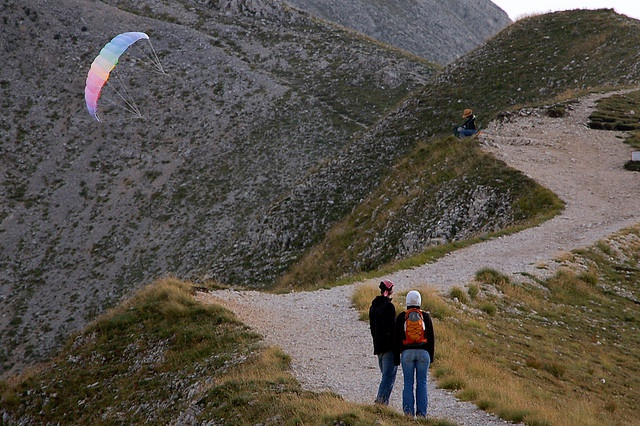Describe the objects in this image and their specific colors. I can see people in black, navy, maroon, and darkblue tones, people in black, navy, darkgray, and gray tones, kite in black, darkgray, lightpink, pink, and lightgray tones, backpack in black, maroon, and brown tones, and people in black, navy, gray, and maroon tones in this image. 